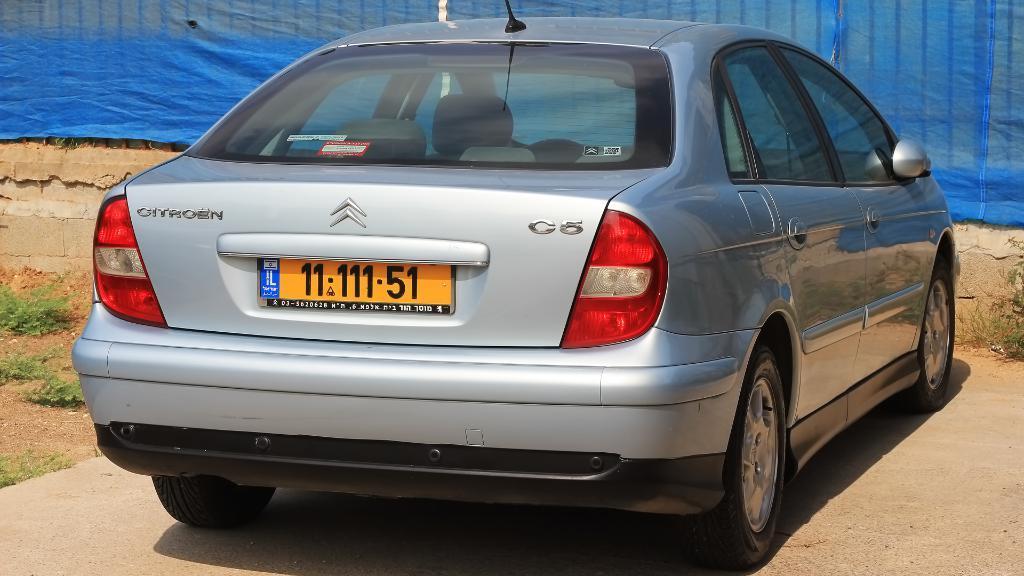Can you describe this image briefly? This picture is clicked outside. In the center we can see a car parked on the ground and we can see the green leaves. In the background we can see a blue color curtain and some other objects. 